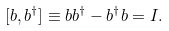<formula> <loc_0><loc_0><loc_500><loc_500>[ b , b ^ { \dagger } ] \equiv b b ^ { \dagger } - b ^ { \dagger } b = I .</formula> 